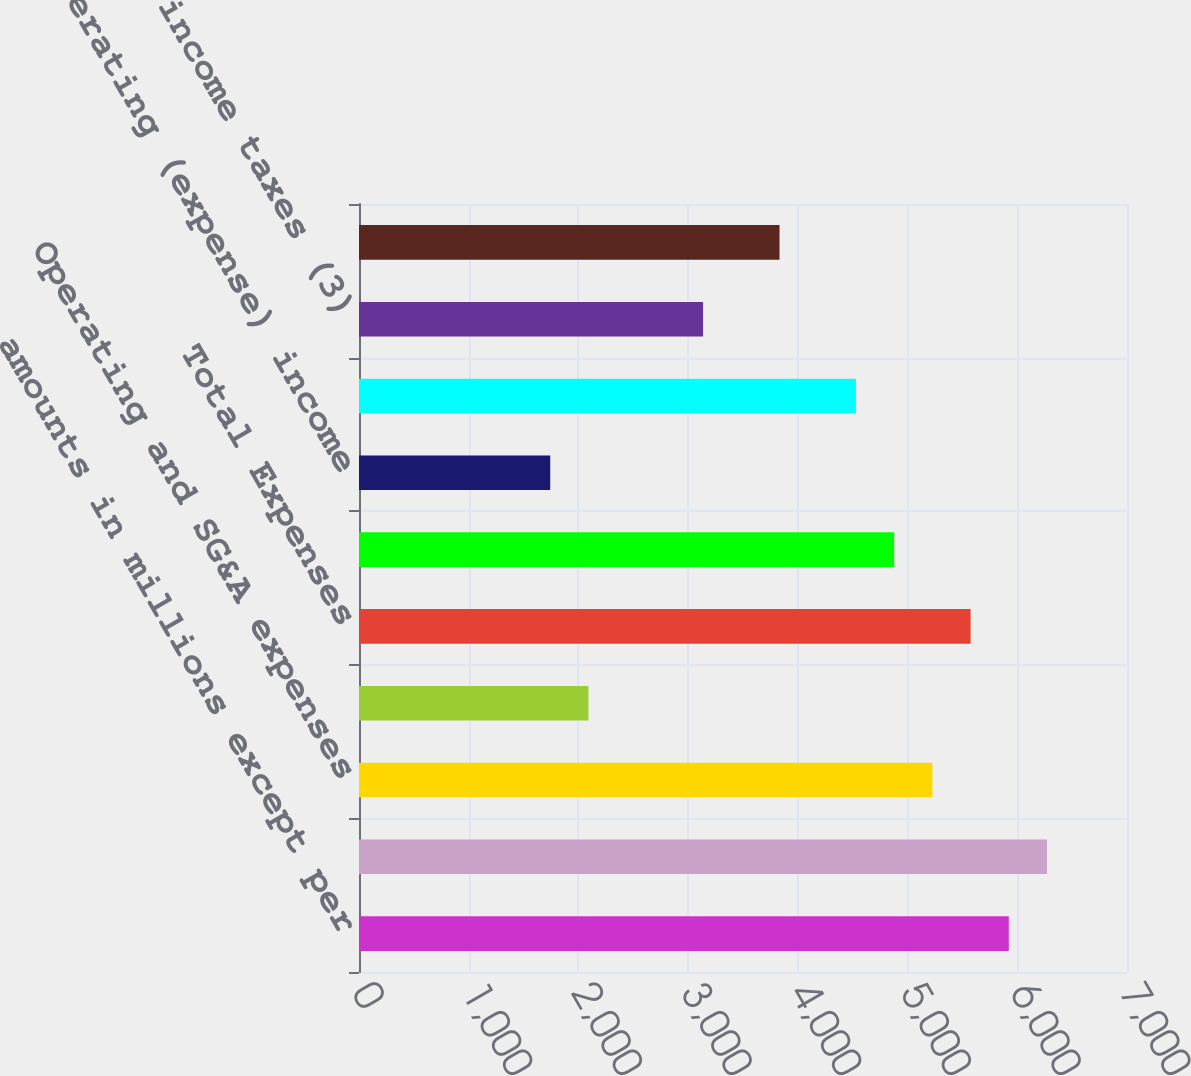Convert chart. <chart><loc_0><loc_0><loc_500><loc_500><bar_chart><fcel>amounts in millions except per<fcel>Revenue<fcel>Operating and SG&A expenses<fcel>Depreciation and amortization<fcel>Total Expenses<fcel>Operating income (1)<fcel>Non-operating (expense) income<fcel>Income before provision for<fcel>Provision for income taxes (3)<fcel>Net income (1)<nl><fcel>5922.66<fcel>6270.97<fcel>5226.04<fcel>2091.25<fcel>5574.35<fcel>4877.73<fcel>1742.94<fcel>4529.42<fcel>3136.18<fcel>3832.8<nl></chart> 